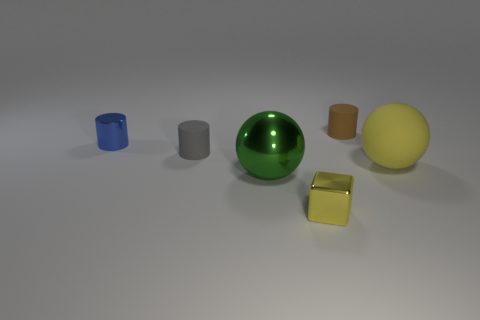Do the small matte object that is behind the gray object and the metallic sphere have the same color?
Your answer should be compact. No. How many objects are either small things left of the metallic block or small cylinders on the right side of the large green metallic object?
Provide a succinct answer. 3. What number of small objects are behind the big shiny object and on the right side of the large metallic object?
Your answer should be very brief. 1. Is the material of the cube the same as the brown cylinder?
Offer a terse response. No. There is a small rubber thing behind the small blue metallic object that is on the left side of the tiny rubber thing behind the metal cylinder; what is its shape?
Your answer should be compact. Cylinder. There is a small object that is in front of the brown object and right of the gray thing; what is its material?
Keep it short and to the point. Metal. There is a object that is behind the small blue metal cylinder that is on the left side of the small rubber cylinder to the right of the small block; what is its color?
Provide a short and direct response. Brown. What number of yellow objects are rubber cubes or metallic objects?
Offer a terse response. 1. How many other things are the same size as the yellow ball?
Ensure brevity in your answer.  1. How many big gray spheres are there?
Your response must be concise. 0. 